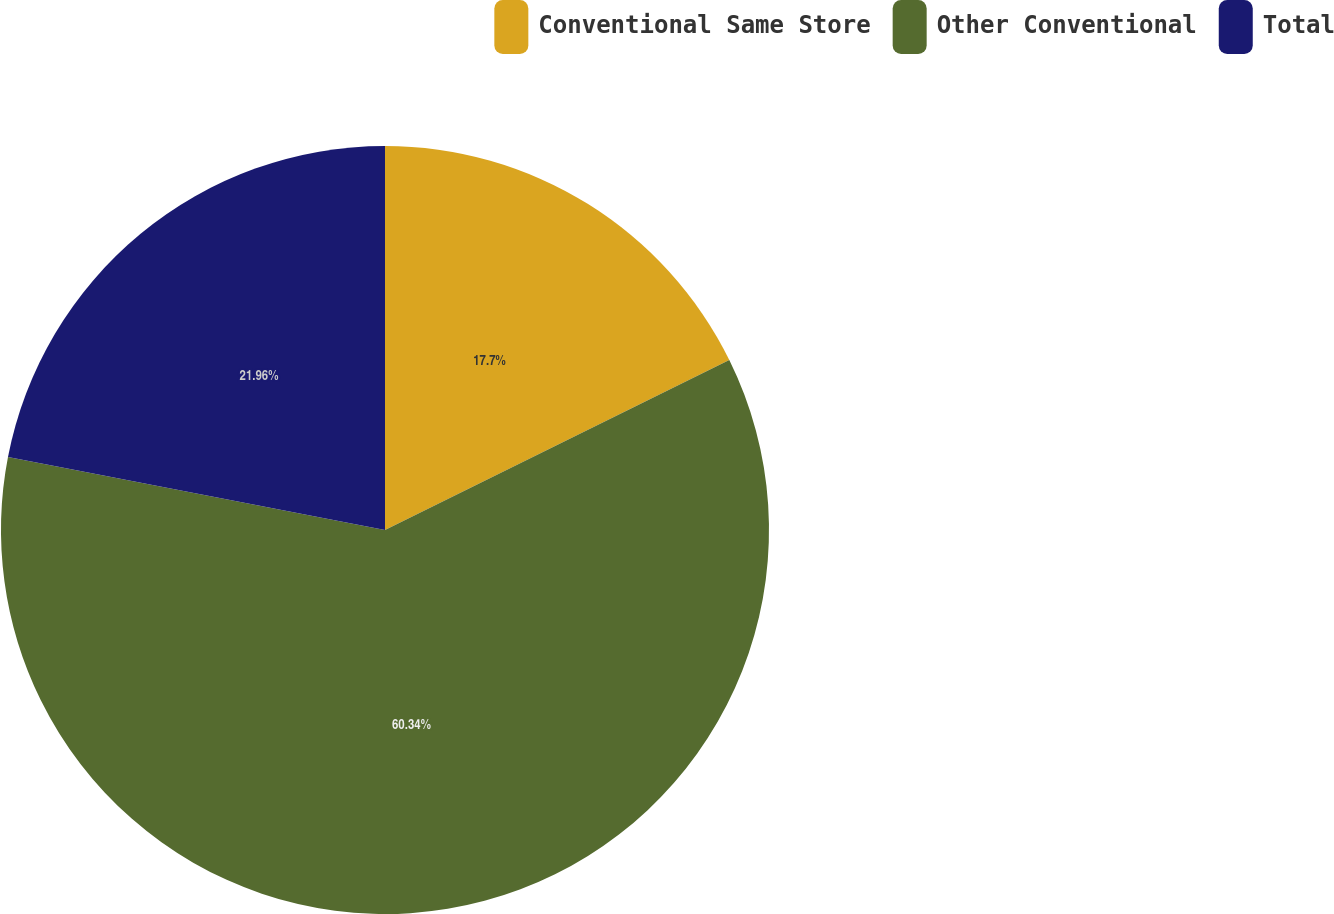Convert chart. <chart><loc_0><loc_0><loc_500><loc_500><pie_chart><fcel>Conventional Same Store<fcel>Other Conventional<fcel>Total<nl><fcel>17.7%<fcel>60.34%<fcel>21.96%<nl></chart> 